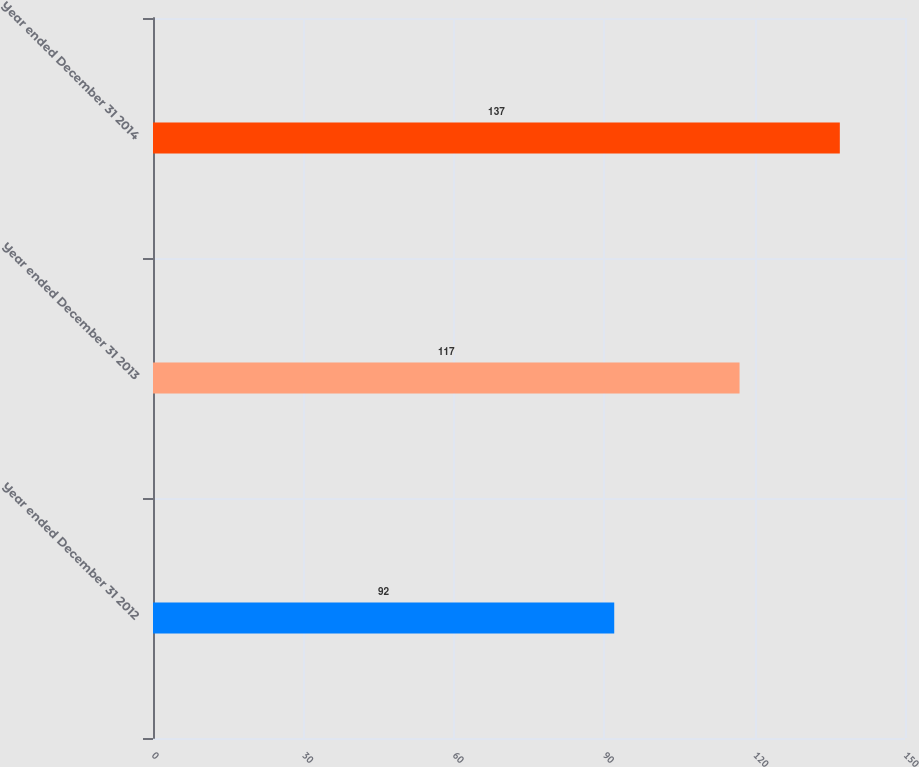<chart> <loc_0><loc_0><loc_500><loc_500><bar_chart><fcel>Year ended December 31 2012<fcel>Year ended December 31 2013<fcel>Year ended December 31 2014<nl><fcel>92<fcel>117<fcel>137<nl></chart> 